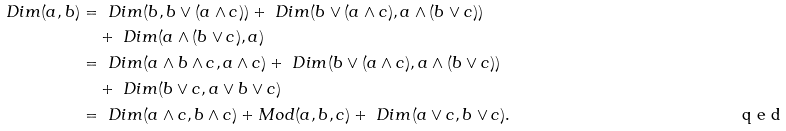Convert formula to latex. <formula><loc_0><loc_0><loc_500><loc_500>\ D i m ( a , b ) & = \ D i m ( b , b \vee ( a \wedge c ) ) + \ D i m ( b \vee ( a \wedge c ) , a \wedge ( b \vee c ) ) \\ & \quad + \ D i m ( a \wedge ( b \vee c ) , a ) \\ & = \ D i m ( a \wedge b \wedge c , a \wedge c ) + \ D i m ( b \vee ( a \wedge c ) , a \wedge ( b \vee c ) ) \\ & \quad + \ D i m ( b \vee c , a \vee b \vee c ) \\ & = \ D i m ( a \wedge c , b \wedge c ) + M o d ( a , b , c ) + \ D i m ( a \vee c , b \vee c ) . \tag* { \ q e d }</formula> 